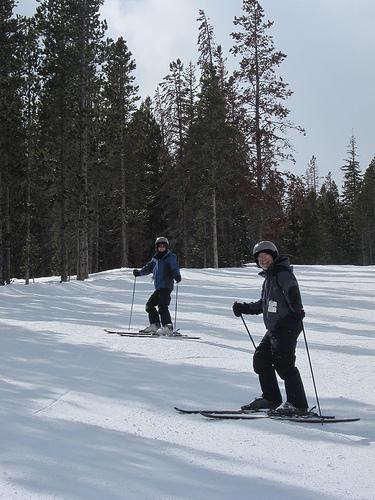How many dinosaurs are in the picture?
Give a very brief answer. 0. How many people are riding on elephants?
Give a very brief answer. 0. 